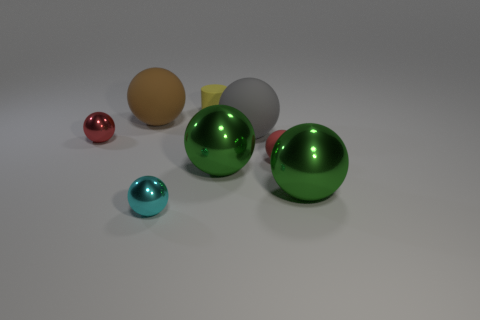How does the presence of multiple spheres of different sizes and colors affect the composition of this image? The presence of multiple spheres varying in sizes and colors creates visual interest and depth in the composition. The contrast in sizes leads the viewer's eye through the image, and the variety of colors provides a pleasing aesthetic balance. It engages the observer by showcasing the beauty of simplicity and geometry in a staged, almost surreal arrangement. 